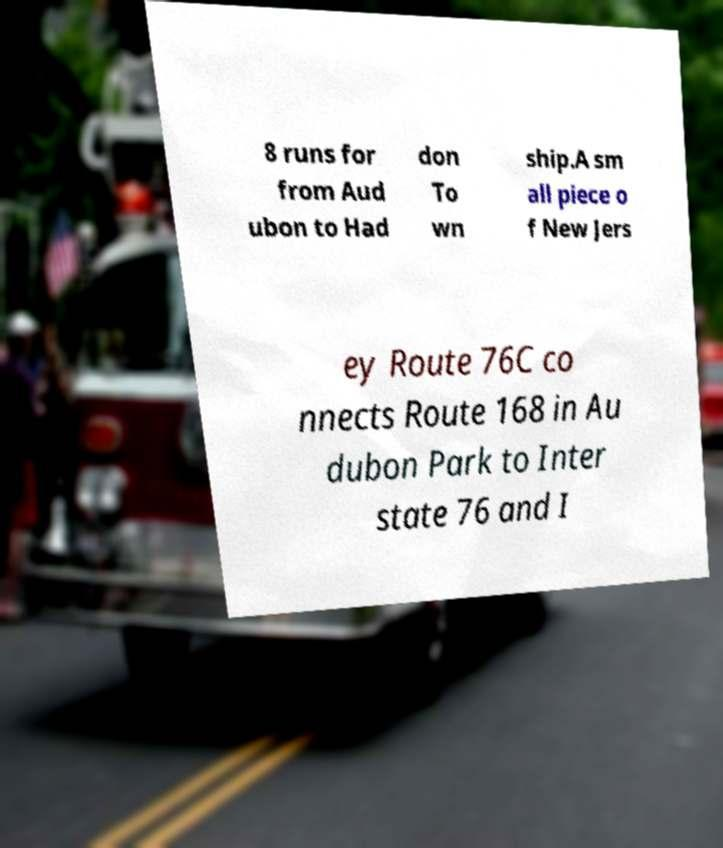There's text embedded in this image that I need extracted. Can you transcribe it verbatim? 8 runs for from Aud ubon to Had don To wn ship.A sm all piece o f New Jers ey Route 76C co nnects Route 168 in Au dubon Park to Inter state 76 and I 